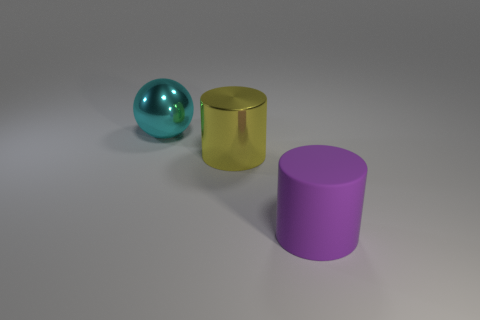There is a object that is both in front of the cyan object and behind the rubber cylinder; what shape is it?
Give a very brief answer. Cylinder. There is another big object that is the same material as the large cyan thing; what shape is it?
Offer a terse response. Cylinder. Are any large cyan metallic spheres visible?
Provide a succinct answer. Yes. Is there a cylinder that is on the right side of the big cylinder behind the large purple cylinder?
Offer a terse response. Yes. What is the material of the purple object that is the same shape as the big yellow shiny thing?
Make the answer very short. Rubber. Are there more green balls than cyan metal balls?
Make the answer very short. No. The object that is both in front of the cyan object and to the left of the purple cylinder is what color?
Give a very brief answer. Yellow. How many other objects are there of the same material as the cyan object?
Your answer should be very brief. 1. Is the number of matte objects less than the number of tiny purple metallic cubes?
Your answer should be compact. No. Is the cyan thing made of the same material as the large cylinder that is behind the big rubber cylinder?
Your response must be concise. Yes. 